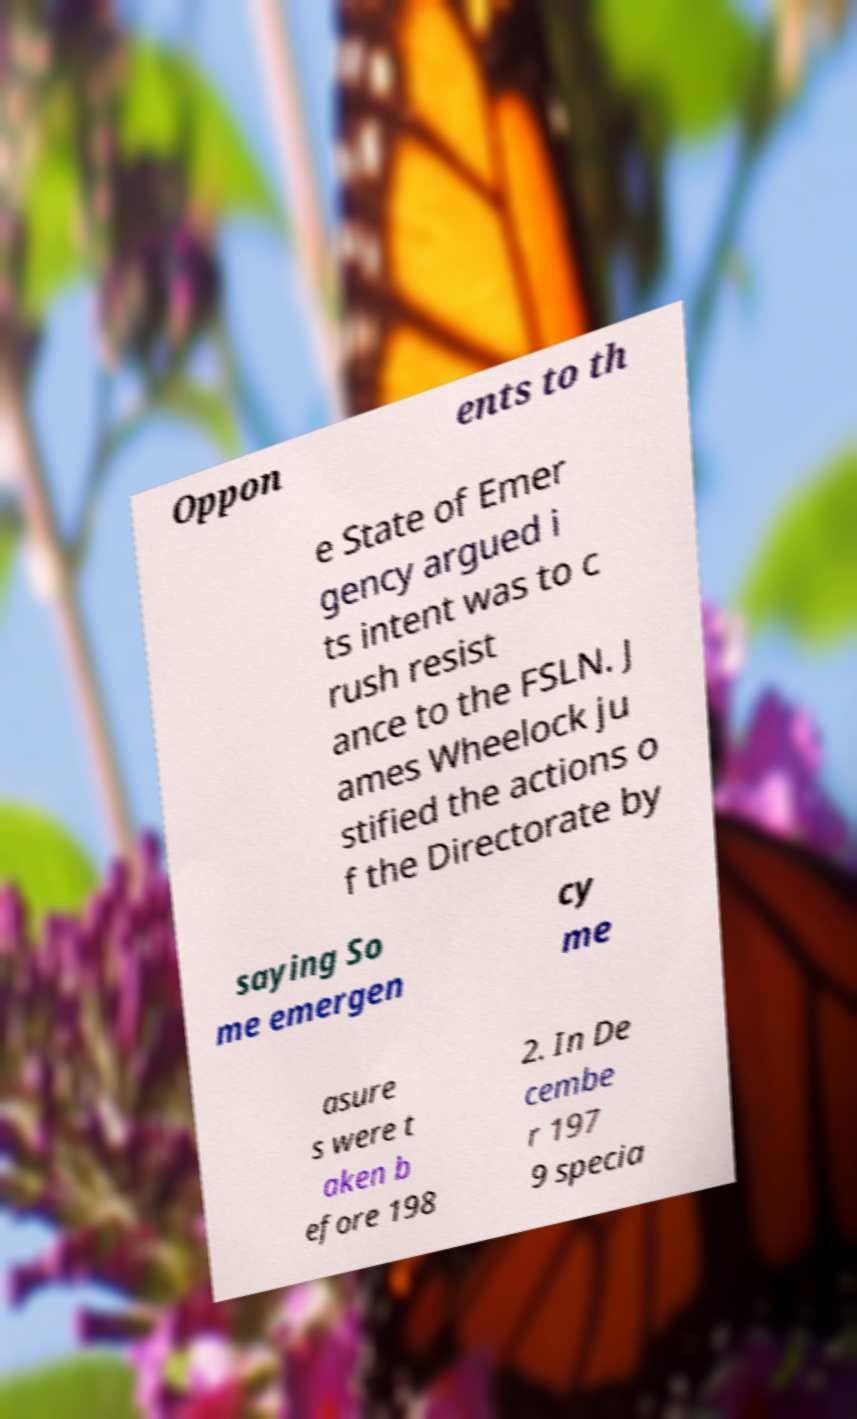Please read and relay the text visible in this image. What does it say? Oppon ents to th e State of Emer gency argued i ts intent was to c rush resist ance to the FSLN. J ames Wheelock ju stified the actions o f the Directorate by saying So me emergen cy me asure s were t aken b efore 198 2. In De cembe r 197 9 specia 